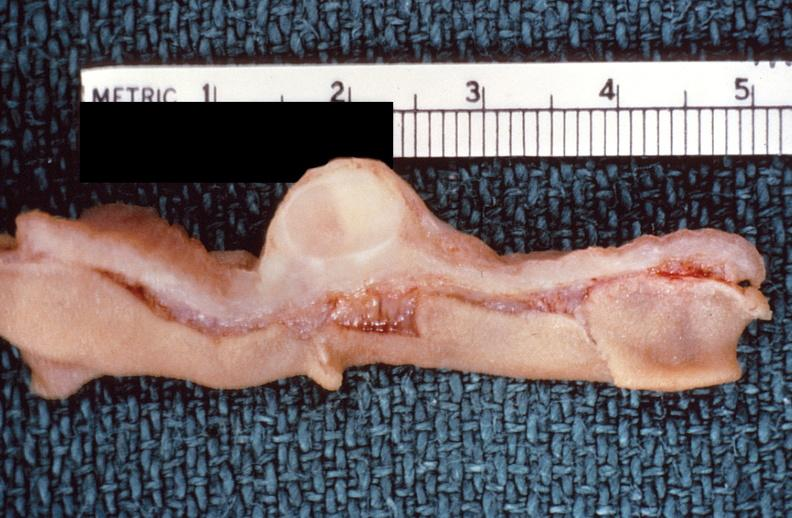does chromophobe adenoma show intestine, leiomyoma?
Answer the question using a single word or phrase. No 